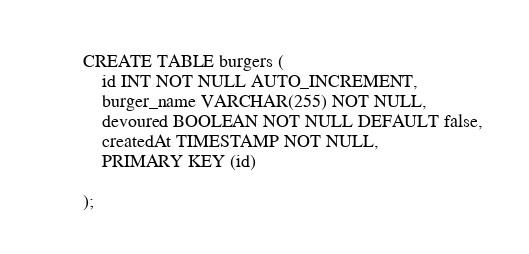Convert code to text. <code><loc_0><loc_0><loc_500><loc_500><_SQL_>
CREATE TABLE burgers (
    id INT NOT NULL AUTO_INCREMENT,
    burger_name VARCHAR(255) NOT NULL,
    devoured BOOLEAN NOT NULL DEFAULT false,
    createdAt TIMESTAMP NOT NULL,
    PRIMARY KEY (id)

);</code> 